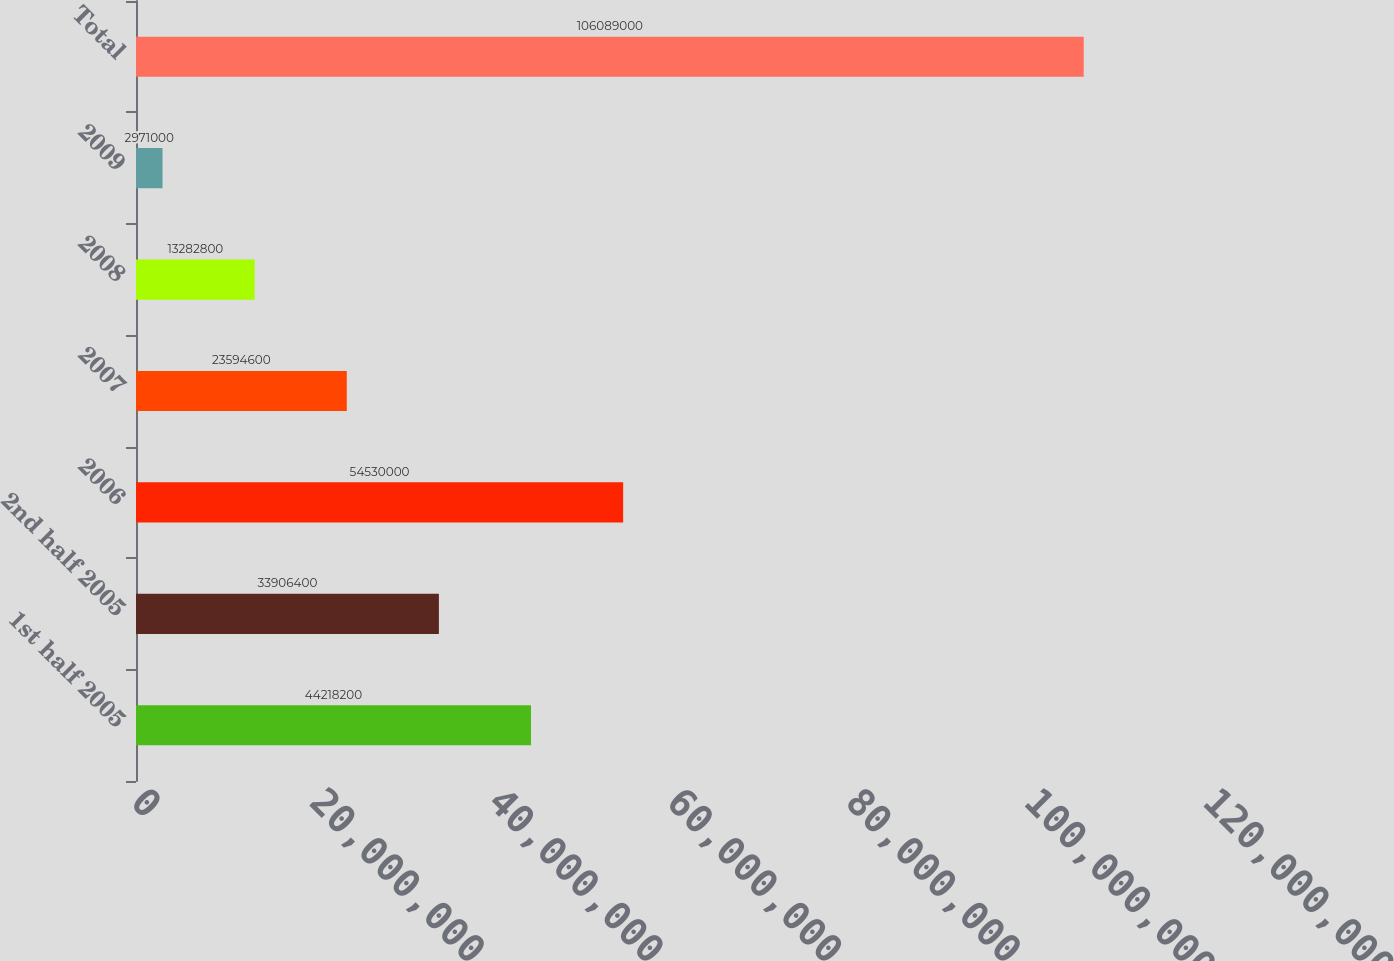<chart> <loc_0><loc_0><loc_500><loc_500><bar_chart><fcel>1st half 2005<fcel>2nd half 2005<fcel>2006<fcel>2007<fcel>2008<fcel>2009<fcel>Total<nl><fcel>4.42182e+07<fcel>3.39064e+07<fcel>5.453e+07<fcel>2.35946e+07<fcel>1.32828e+07<fcel>2.971e+06<fcel>1.06089e+08<nl></chart> 